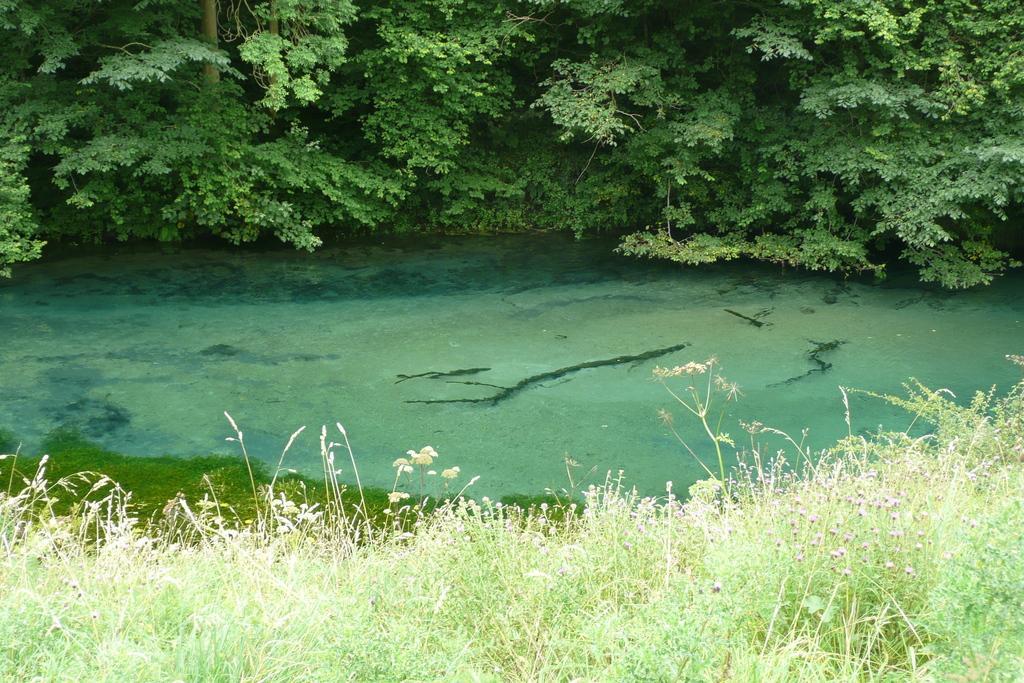Could you give a brief overview of what you see in this image? In this image there are plants, grass, water and trees. 